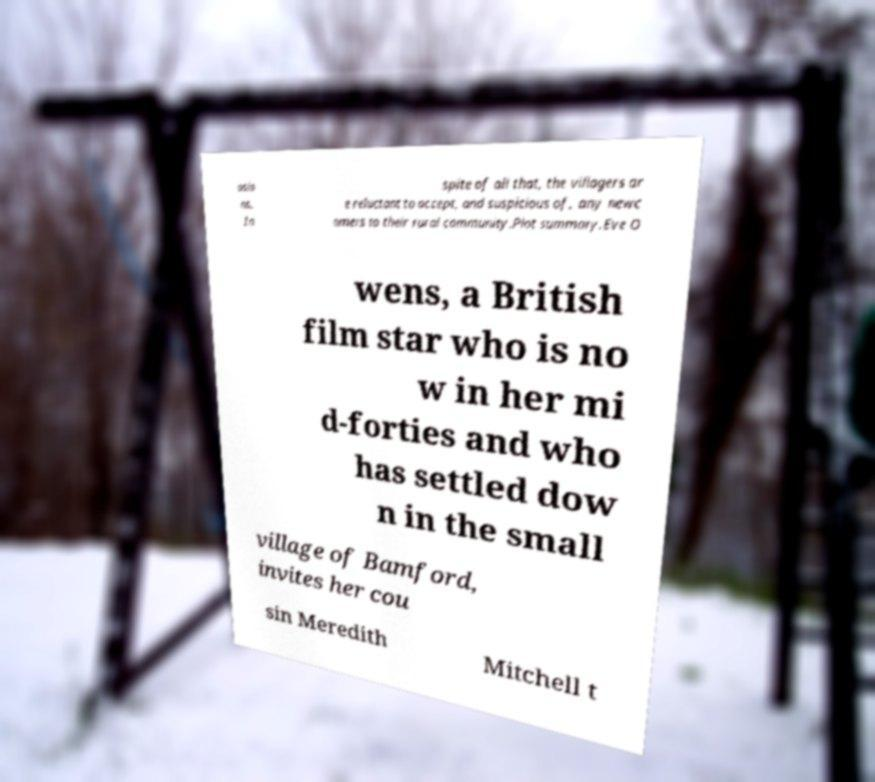What messages or text are displayed in this image? I need them in a readable, typed format. asio ns. In spite of all that, the villagers ar e reluctant to accept, and suspicious of, any newc omers to their rural community.Plot summary.Eve O wens, a British film star who is no w in her mi d-forties and who has settled dow n in the small village of Bamford, invites her cou sin Meredith Mitchell t 